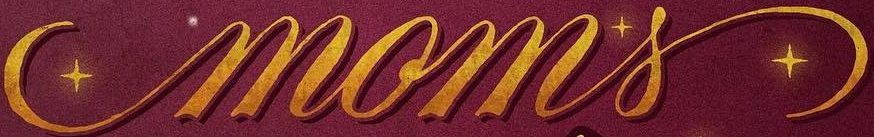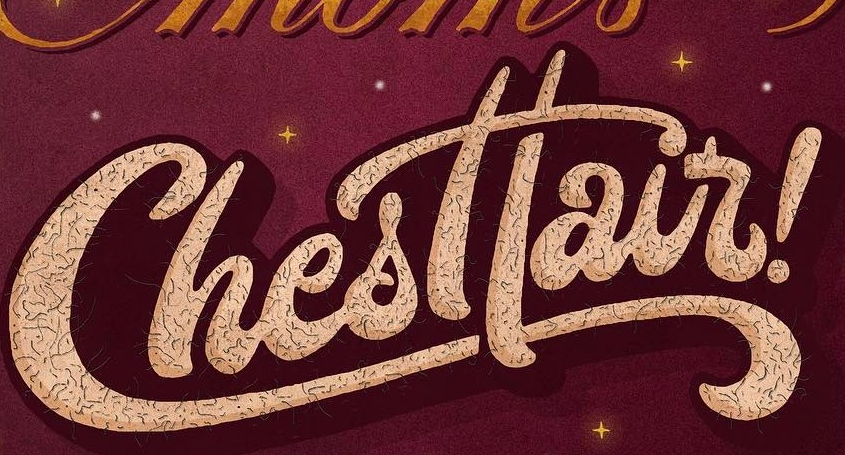Read the text content from these images in order, separated by a semicolon. moms; Chesttair 